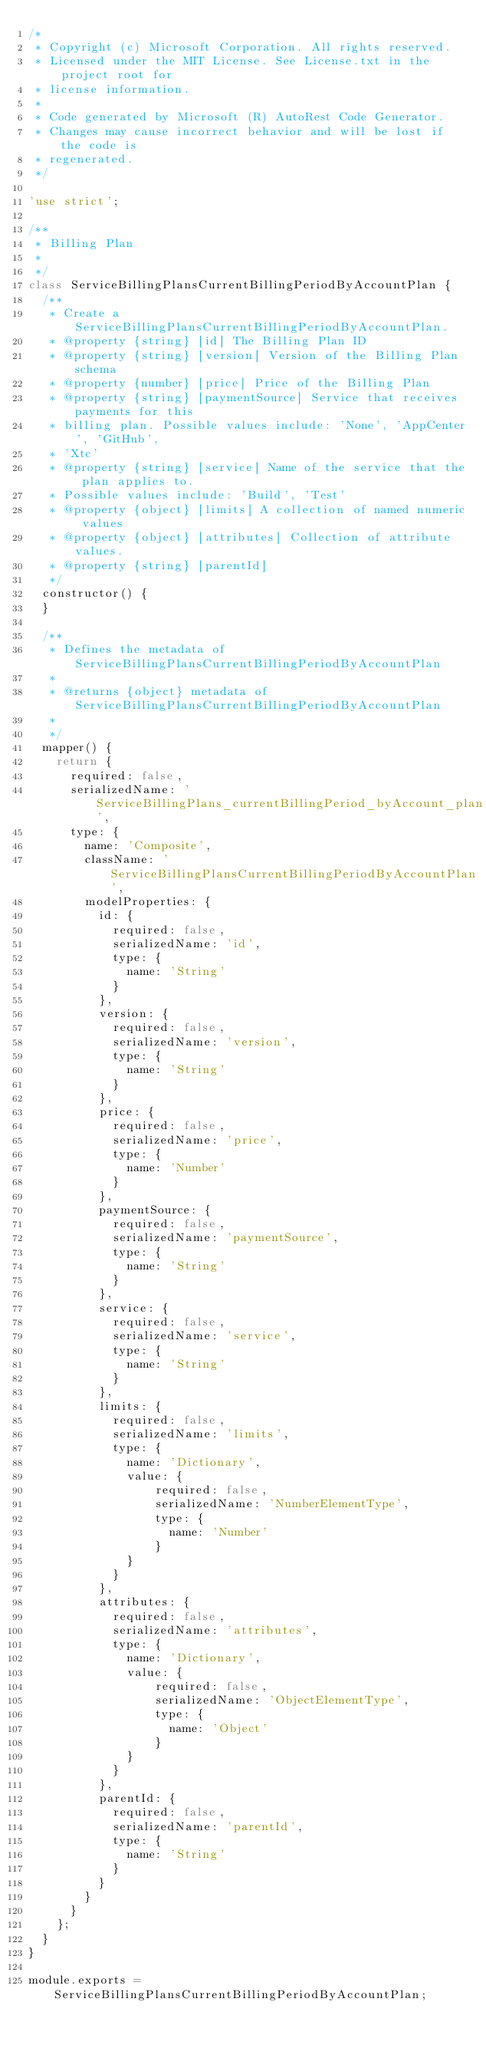Convert code to text. <code><loc_0><loc_0><loc_500><loc_500><_JavaScript_>/*
 * Copyright (c) Microsoft Corporation. All rights reserved.
 * Licensed under the MIT License. See License.txt in the project root for
 * license information.
 *
 * Code generated by Microsoft (R) AutoRest Code Generator.
 * Changes may cause incorrect behavior and will be lost if the code is
 * regenerated.
 */

'use strict';

/**
 * Billing Plan
 *
 */
class ServiceBillingPlansCurrentBillingPeriodByAccountPlan {
  /**
   * Create a ServiceBillingPlansCurrentBillingPeriodByAccountPlan.
   * @property {string} [id] The Billing Plan ID
   * @property {string} [version] Version of the Billing Plan schema
   * @property {number} [price] Price of the Billing Plan
   * @property {string} [paymentSource] Service that receives payments for this
   * billing plan. Possible values include: 'None', 'AppCenter', 'GitHub',
   * 'Xtc'
   * @property {string} [service] Name of the service that the plan applies to.
   * Possible values include: 'Build', 'Test'
   * @property {object} [limits] A collection of named numeric values
   * @property {object} [attributes] Collection of attribute values.
   * @property {string} [parentId]
   */
  constructor() {
  }

  /**
   * Defines the metadata of ServiceBillingPlansCurrentBillingPeriodByAccountPlan
   *
   * @returns {object} metadata of ServiceBillingPlansCurrentBillingPeriodByAccountPlan
   *
   */
  mapper() {
    return {
      required: false,
      serializedName: 'ServiceBillingPlans_currentBillingPeriod_byAccount_plan',
      type: {
        name: 'Composite',
        className: 'ServiceBillingPlansCurrentBillingPeriodByAccountPlan',
        modelProperties: {
          id: {
            required: false,
            serializedName: 'id',
            type: {
              name: 'String'
            }
          },
          version: {
            required: false,
            serializedName: 'version',
            type: {
              name: 'String'
            }
          },
          price: {
            required: false,
            serializedName: 'price',
            type: {
              name: 'Number'
            }
          },
          paymentSource: {
            required: false,
            serializedName: 'paymentSource',
            type: {
              name: 'String'
            }
          },
          service: {
            required: false,
            serializedName: 'service',
            type: {
              name: 'String'
            }
          },
          limits: {
            required: false,
            serializedName: 'limits',
            type: {
              name: 'Dictionary',
              value: {
                  required: false,
                  serializedName: 'NumberElementType',
                  type: {
                    name: 'Number'
                  }
              }
            }
          },
          attributes: {
            required: false,
            serializedName: 'attributes',
            type: {
              name: 'Dictionary',
              value: {
                  required: false,
                  serializedName: 'ObjectElementType',
                  type: {
                    name: 'Object'
                  }
              }
            }
          },
          parentId: {
            required: false,
            serializedName: 'parentId',
            type: {
              name: 'String'
            }
          }
        }
      }
    };
  }
}

module.exports = ServiceBillingPlansCurrentBillingPeriodByAccountPlan;
</code> 